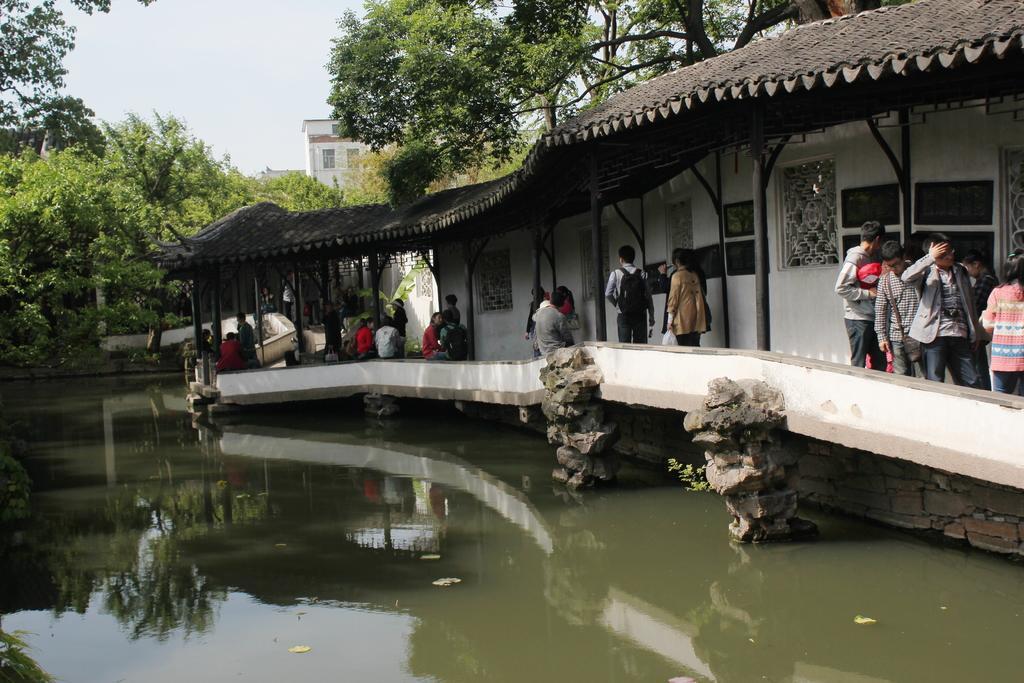Please provide a concise description of this image. In the picture I can see few persons in the right corner and there is water beside them and there are trees and a building in the background. 